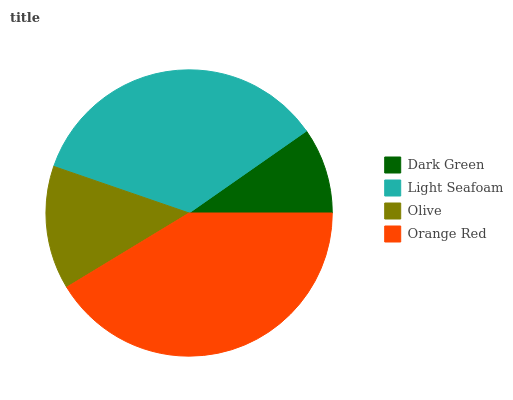Is Dark Green the minimum?
Answer yes or no. Yes. Is Orange Red the maximum?
Answer yes or no. Yes. Is Light Seafoam the minimum?
Answer yes or no. No. Is Light Seafoam the maximum?
Answer yes or no. No. Is Light Seafoam greater than Dark Green?
Answer yes or no. Yes. Is Dark Green less than Light Seafoam?
Answer yes or no. Yes. Is Dark Green greater than Light Seafoam?
Answer yes or no. No. Is Light Seafoam less than Dark Green?
Answer yes or no. No. Is Light Seafoam the high median?
Answer yes or no. Yes. Is Olive the low median?
Answer yes or no. Yes. Is Dark Green the high median?
Answer yes or no. No. Is Dark Green the low median?
Answer yes or no. No. 